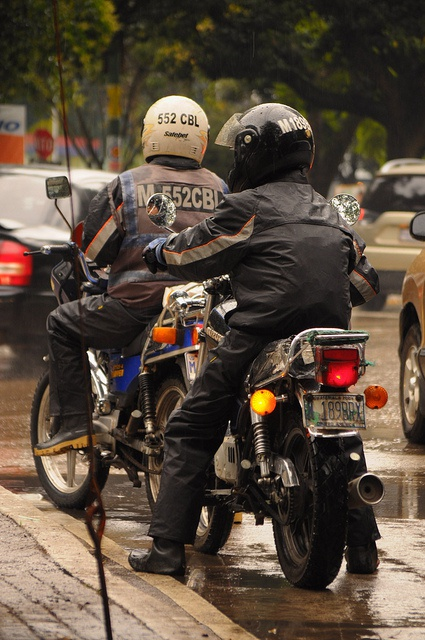Describe the objects in this image and their specific colors. I can see people in black and gray tones, motorcycle in black, gray, and maroon tones, people in black, gray, tan, and maroon tones, motorcycle in black, gray, and maroon tones, and car in black, lightgray, and tan tones in this image. 